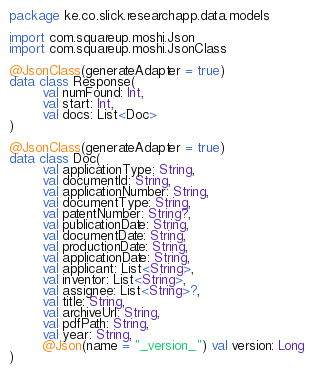Convert code to text. <code><loc_0><loc_0><loc_500><loc_500><_Kotlin_>package ke.co.slick.researchapp.data.models

import com.squareup.moshi.Json
import com.squareup.moshi.JsonClass

@JsonClass(generateAdapter = true)
data class Response(
        val numFound: Int,
        val start: Int,
        val docs: List<Doc>
)

@JsonClass(generateAdapter = true)
data class Doc(
        val applicationType: String,
        val documentId: String,
        val applicationNumber: String,
        val documentType: String,
        val patentNumber: String?,
        val publicationDate: String,
        val documentDate: String,
        val productionDate: String,
        val applicationDate: String,
        val applicant: List<String>,
        val inventor: List<String>,
        val assignee: List<String>?,
        val title: String,
        val archiveUrl: String,
        val pdfPath: String,
        val year: String,
        @Json(name = "_version_") val version: Long
)</code> 